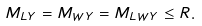<formula> <loc_0><loc_0><loc_500><loc_500>M _ { L Y } = M _ { W Y } = M _ { L W Y } \leq R .</formula> 